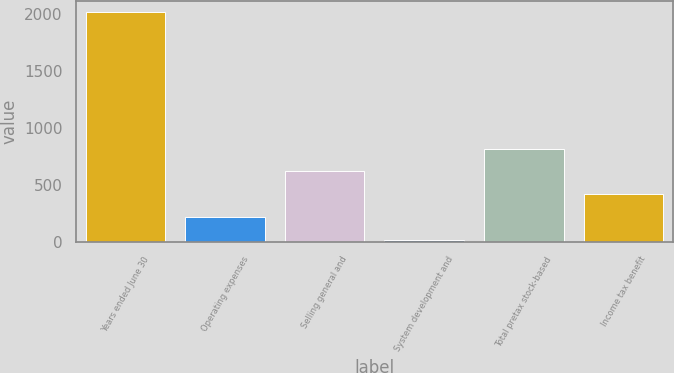Convert chart. <chart><loc_0><loc_0><loc_500><loc_500><bar_chart><fcel>Years ended June 30<fcel>Operating expenses<fcel>Selling general and<fcel>System development and<fcel>Total pretax stock-based<fcel>Income tax benefit<nl><fcel>2017<fcel>218.08<fcel>617.84<fcel>18.2<fcel>817.72<fcel>417.96<nl></chart> 